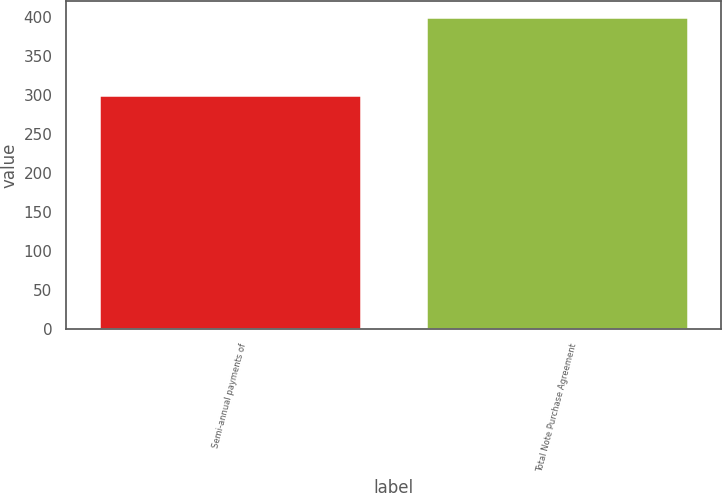<chart> <loc_0><loc_0><loc_500><loc_500><bar_chart><fcel>Semi-annual payments of<fcel>Total Note Purchase Agreement<nl><fcel>300<fcel>400<nl></chart> 